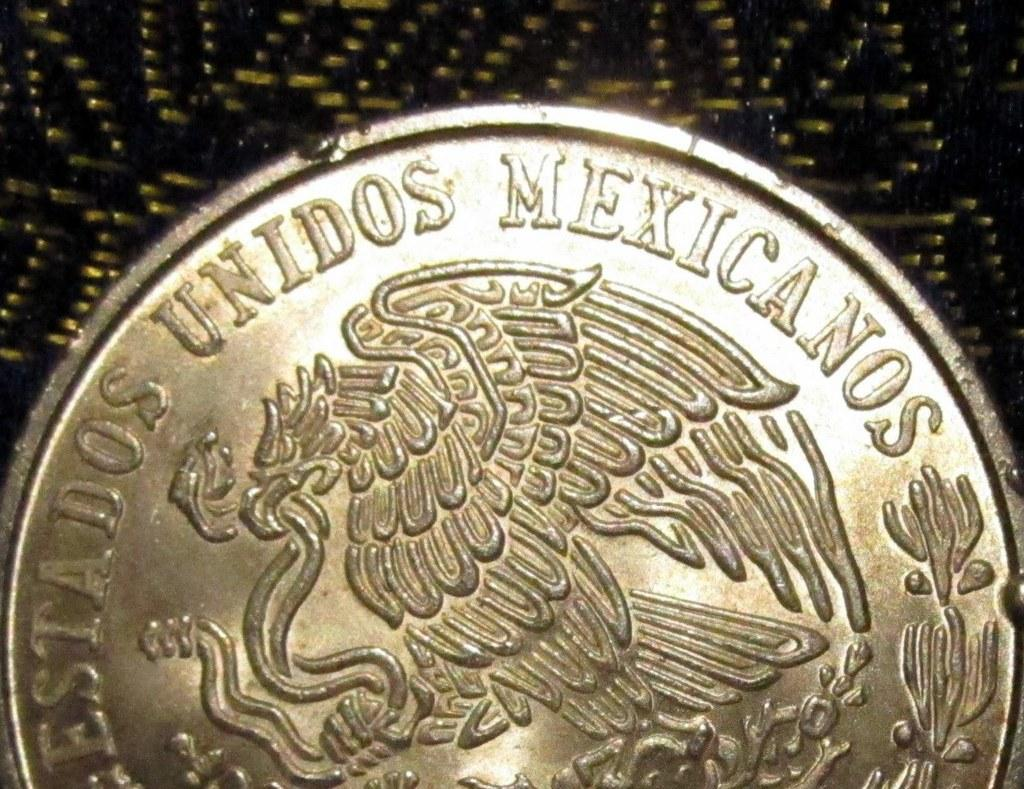<image>
Present a compact description of the photo's key features. A coin with the word Mexicanos also has a large bird on it. 